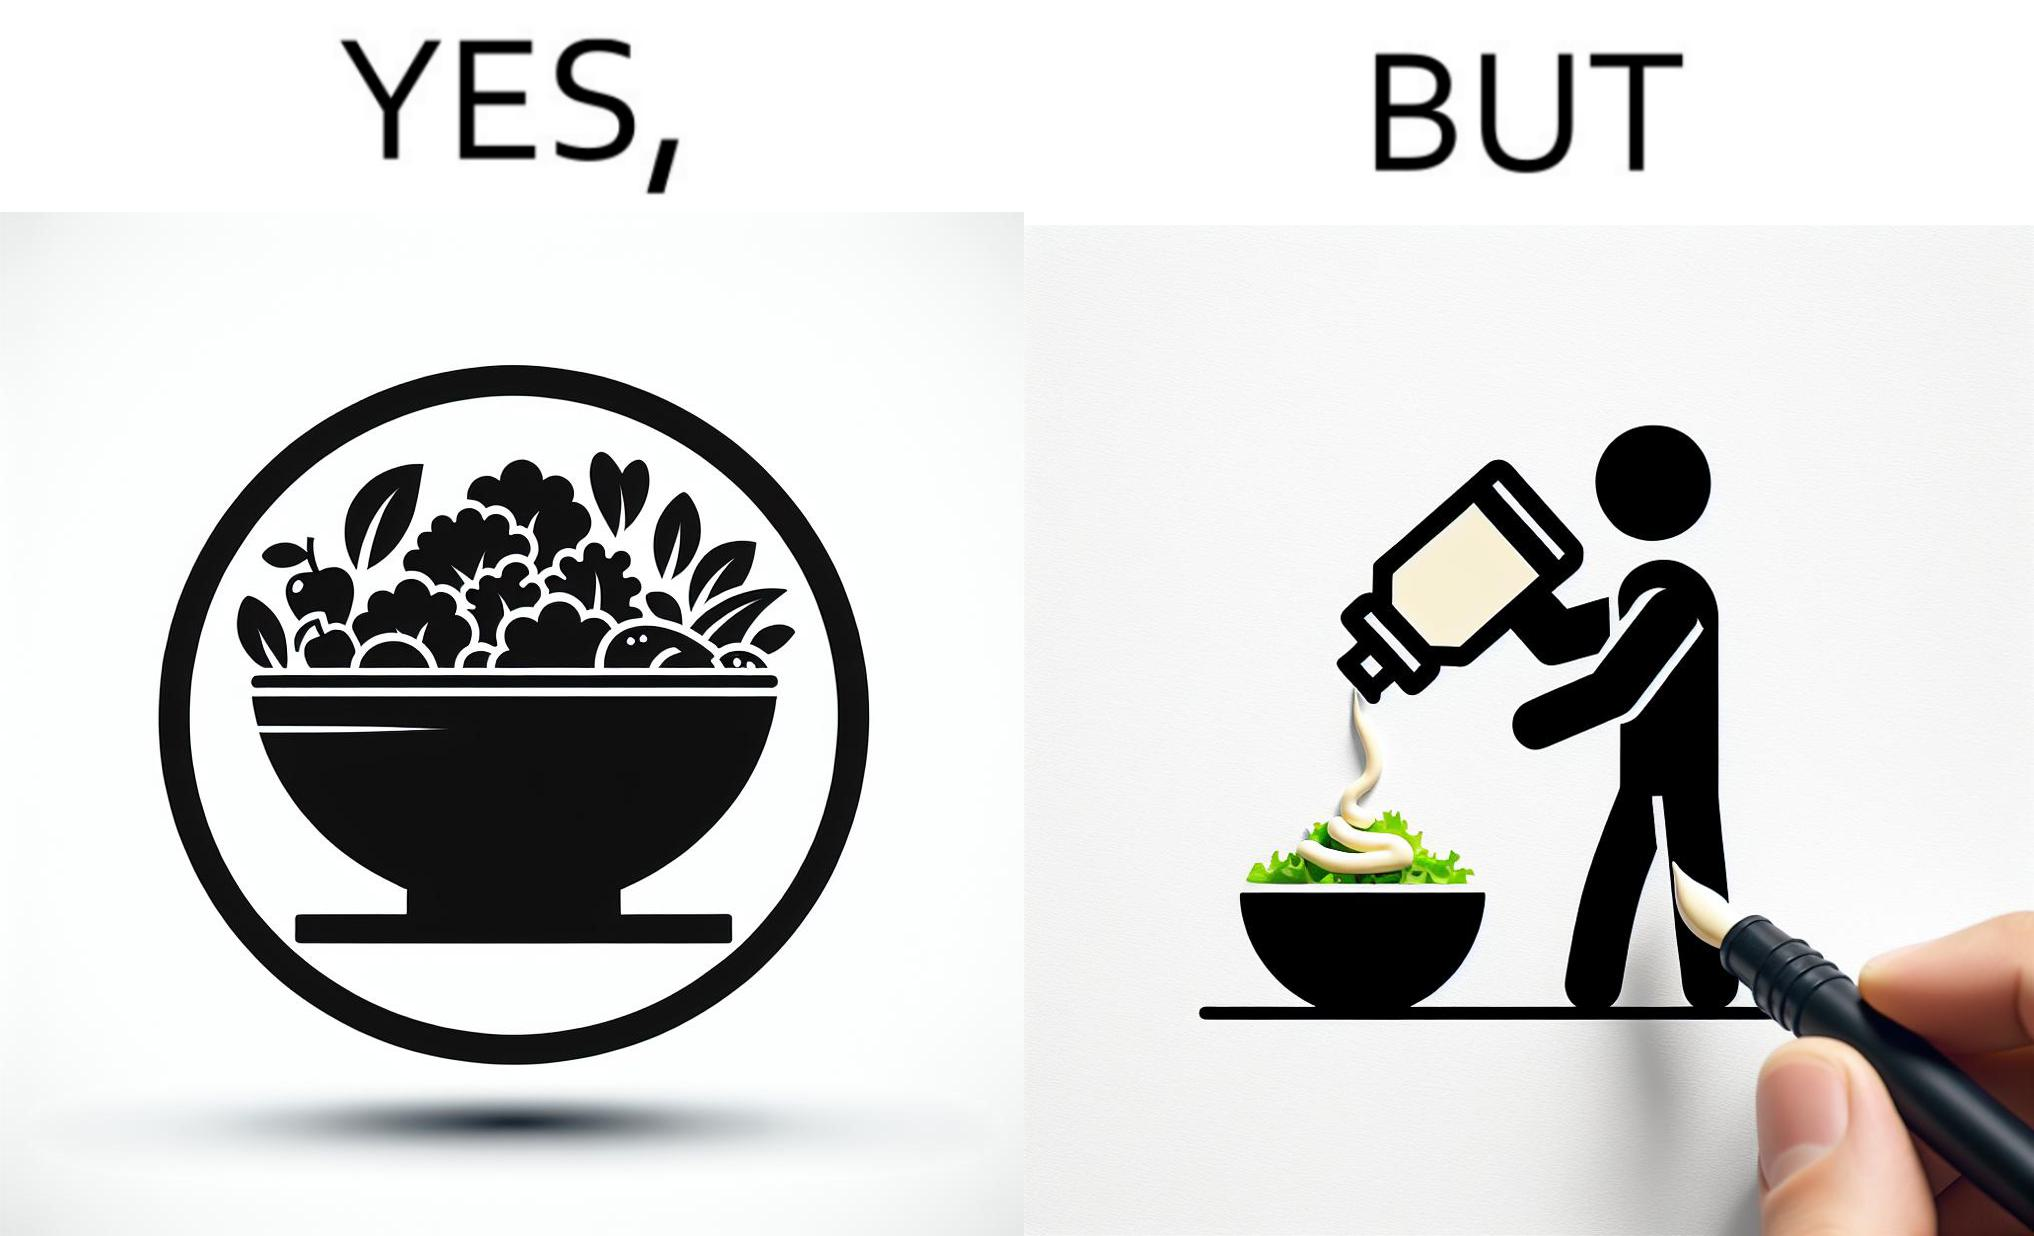Explain the humor or irony in this image. The image is ironical, as salad in a bowl by itself is very healthy. However, when people have it with Mayonnaise sauce to improve the taste, it is not healthy anymore, and defeats the point of having nutrient-rich salad altogether. 